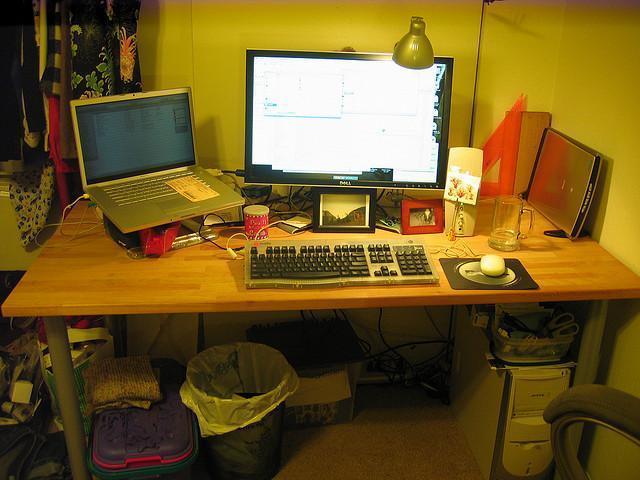How many computers can you see?
Give a very brief answer. 2. How many waste cans are there?
Give a very brief answer. 1. How many laptops are in the photo?
Give a very brief answer. 2. 